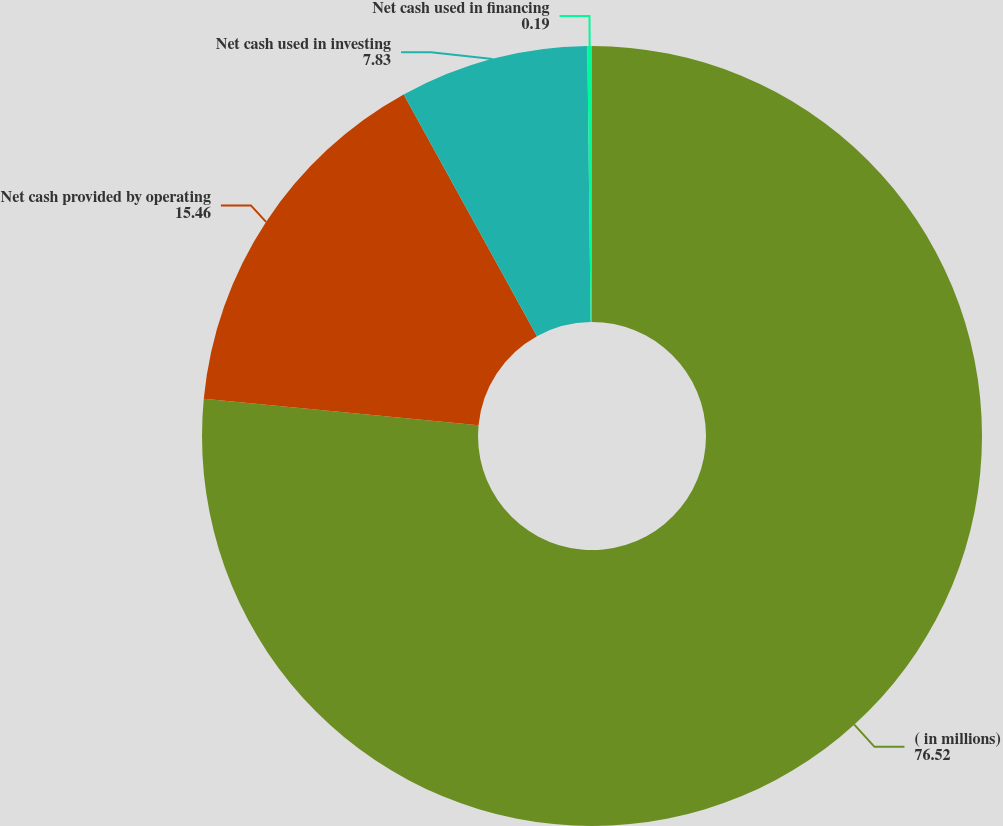Convert chart to OTSL. <chart><loc_0><loc_0><loc_500><loc_500><pie_chart><fcel>( in millions)<fcel>Net cash provided by operating<fcel>Net cash used in investing<fcel>Net cash used in financing<nl><fcel>76.52%<fcel>15.46%<fcel>7.83%<fcel>0.19%<nl></chart> 